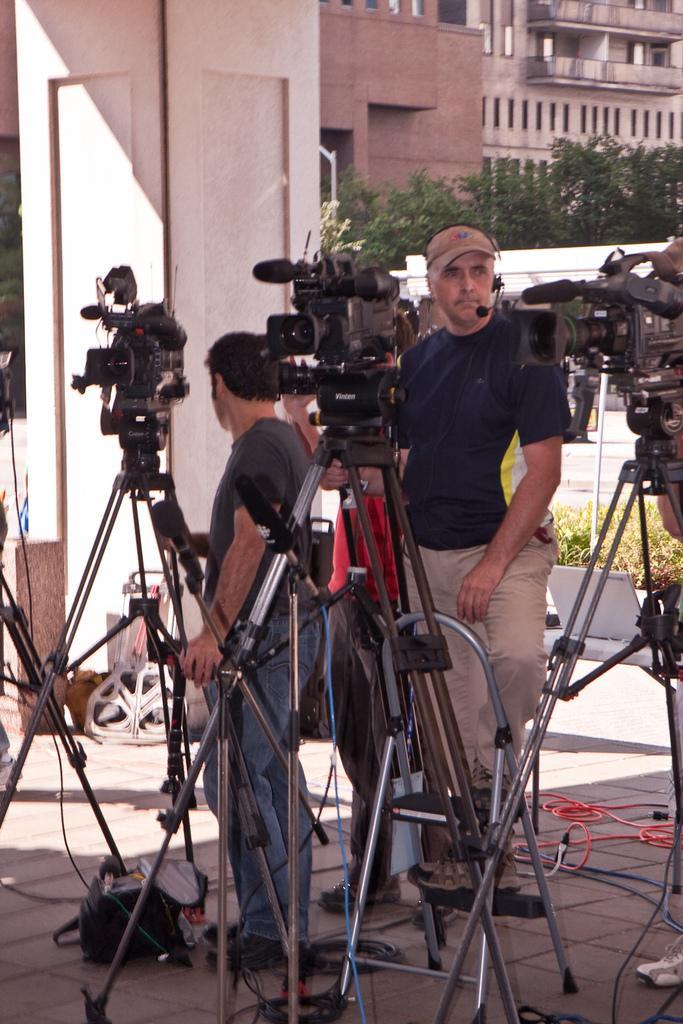In one or two sentences, can you explain what this image depicts? In the picture we can see some cameras on the tripods and near it, we can see three people are standing and holding it and in the background we can see the wall, trees and buildings. 